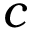<formula> <loc_0><loc_0><loc_500><loc_500>c</formula> 